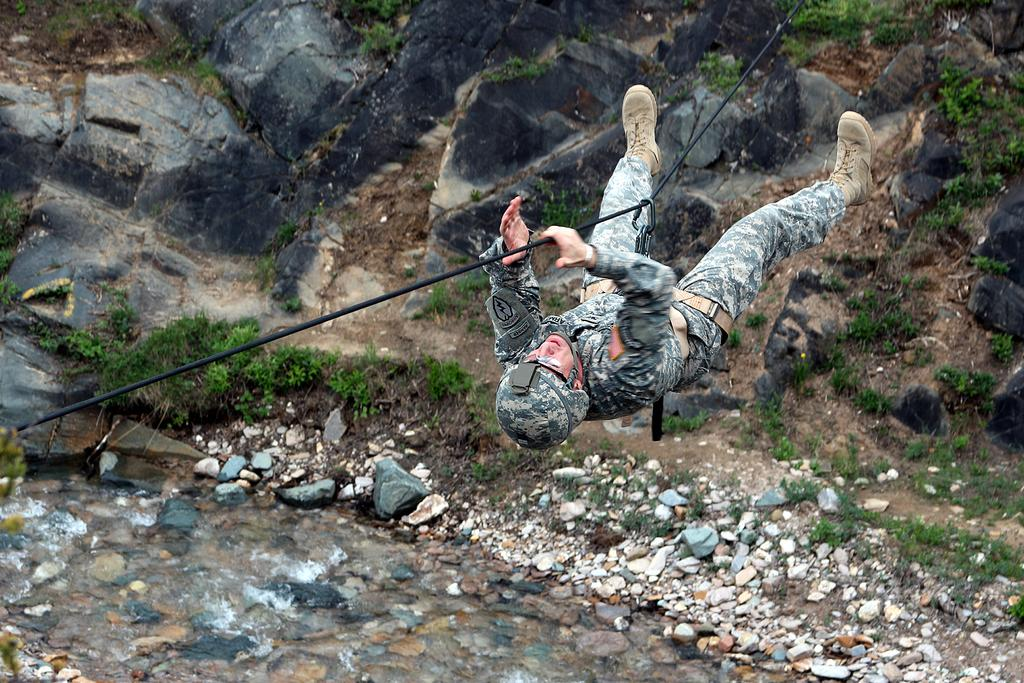What is the main subject of the image? The main subject of the image is a man. What is the man holding in the image? The man is holding a rope in the image. What is the man doing in the image? The man is moving from one end to another in the image. What can be seen in the background of the image? There are rocks, plants, and stones on the ground in the image. What type of protective gear is the man wearing? The man is wearing a helmet, specifically a "wire man helmet." What type of expansion is being performed by the man in the image? There is no expansion being performed by the man in the image; he is simply holding a rope and moving from one end to another. What type of produce is being grown in the image? There is no produce being grown in the image; it features a man holding a rope and moving from one end to another, along with rocks, plants, and stones on the ground. 